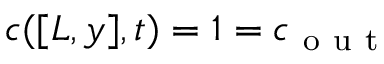<formula> <loc_0><loc_0><loc_500><loc_500>c ( [ L , y ] , t ) = 1 = c _ { o u t }</formula> 